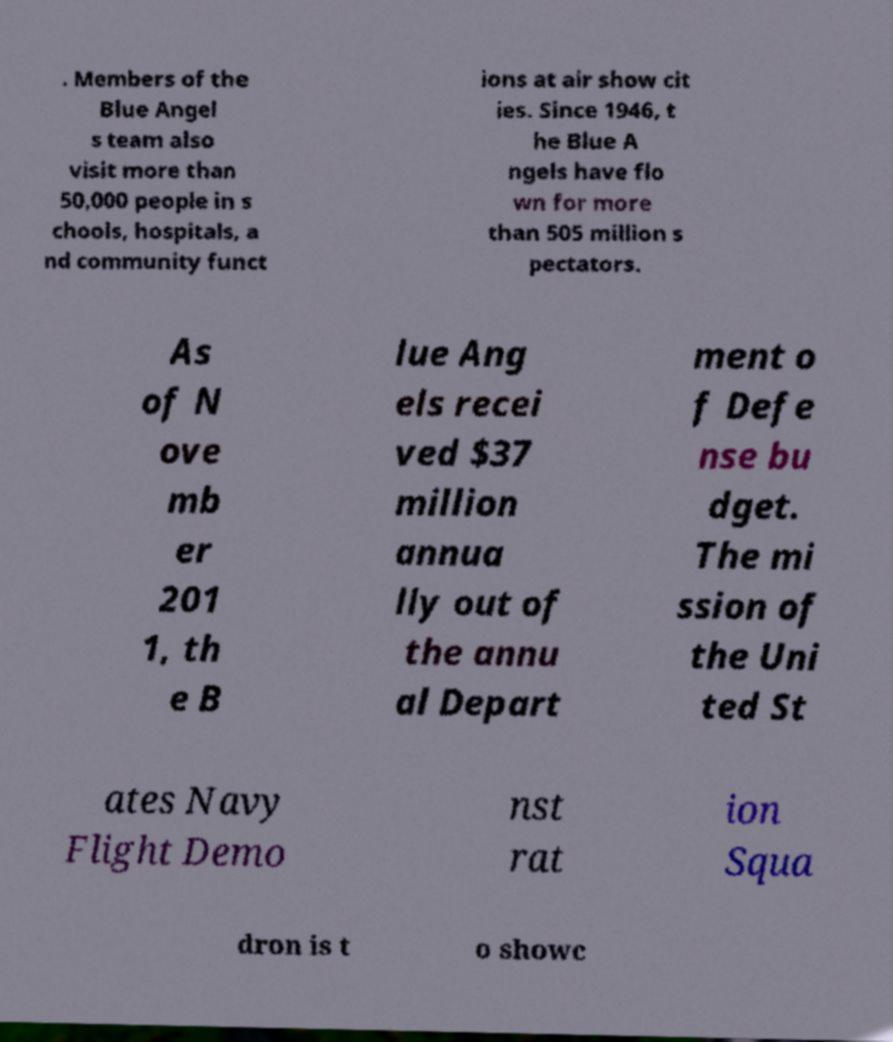I need the written content from this picture converted into text. Can you do that? . Members of the Blue Angel s team also visit more than 50,000 people in s chools, hospitals, a nd community funct ions at air show cit ies. Since 1946, t he Blue A ngels have flo wn for more than 505 million s pectators. As of N ove mb er 201 1, th e B lue Ang els recei ved $37 million annua lly out of the annu al Depart ment o f Defe nse bu dget. The mi ssion of the Uni ted St ates Navy Flight Demo nst rat ion Squa dron is t o showc 